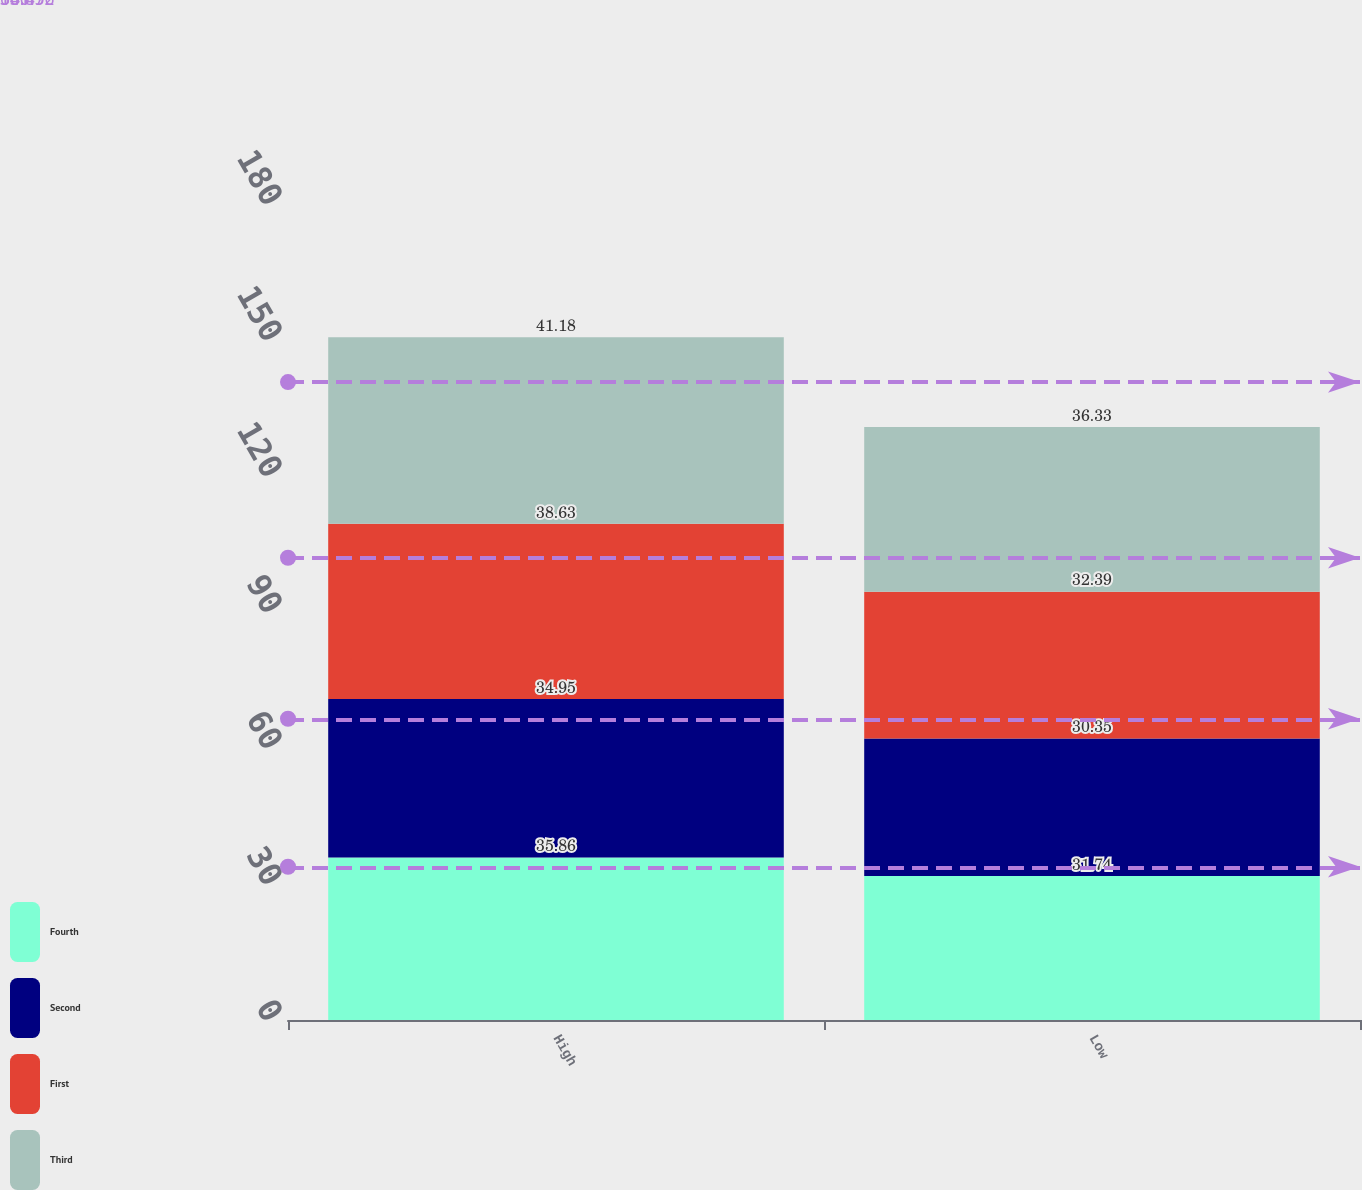Convert chart to OTSL. <chart><loc_0><loc_0><loc_500><loc_500><stacked_bar_chart><ecel><fcel>High<fcel>Low<nl><fcel>Fourth<fcel>35.86<fcel>31.74<nl><fcel>Second<fcel>34.95<fcel>30.35<nl><fcel>First<fcel>38.63<fcel>32.39<nl><fcel>Third<fcel>41.18<fcel>36.33<nl></chart> 